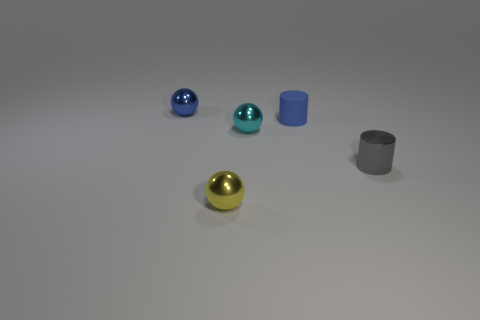There is a cylinder that is the same material as the cyan object; what is its color?
Offer a very short reply. Gray. Are there more small cyan things on the right side of the cyan sphere than yellow shiny balls behind the blue shiny sphere?
Offer a very short reply. No. Is there a matte object?
Provide a short and direct response. Yes. What is the material of the other tiny object that is the same color as the matte thing?
Give a very brief answer. Metal. What number of things are small matte things or cyan metal objects?
Your response must be concise. 2. Are there any other matte objects of the same color as the matte thing?
Provide a succinct answer. No. How many cyan objects are in front of the small cylinder that is in front of the matte object?
Offer a terse response. 0. Is the number of big yellow balls greater than the number of gray metal cylinders?
Provide a short and direct response. No. Is the material of the yellow ball the same as the tiny cyan ball?
Offer a very short reply. Yes. Are there an equal number of spheres that are to the right of the tiny blue rubber cylinder and large blue objects?
Make the answer very short. Yes. 